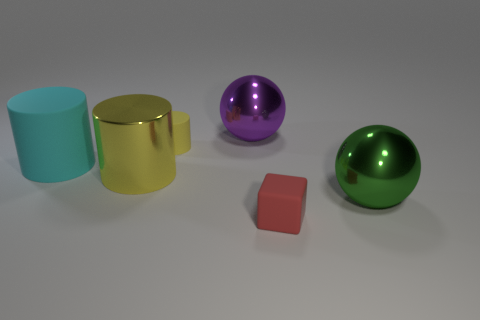What size is the yellow thing that is made of the same material as the cube?
Provide a succinct answer. Small. There is a big yellow thing that is the same shape as the cyan rubber thing; what material is it?
Keep it short and to the point. Metal. Is the color of the small cylinder the same as the metallic cylinder?
Your response must be concise. Yes. Is the size of the shiny ball to the right of the purple object the same as the tiny red thing?
Offer a very short reply. No. Is the number of big cyan rubber cylinders left of the yellow matte object greater than the number of tiny gray metal cylinders?
Ensure brevity in your answer.  Yes. There is a cylinder behind the large cyan cylinder; what number of green metallic things are behind it?
Provide a succinct answer. 0. Is the number of red rubber things that are left of the small red cube less than the number of small red blocks?
Offer a terse response. Yes. Is there a large yellow shiny cylinder to the right of the yellow cylinder that is in front of the big cyan cylinder that is in front of the large purple metallic sphere?
Your answer should be very brief. No. Does the red block have the same material as the big green thing in front of the purple shiny sphere?
Provide a succinct answer. No. What is the color of the big metallic sphere that is in front of the large thing on the left side of the big shiny cylinder?
Keep it short and to the point. Green. 